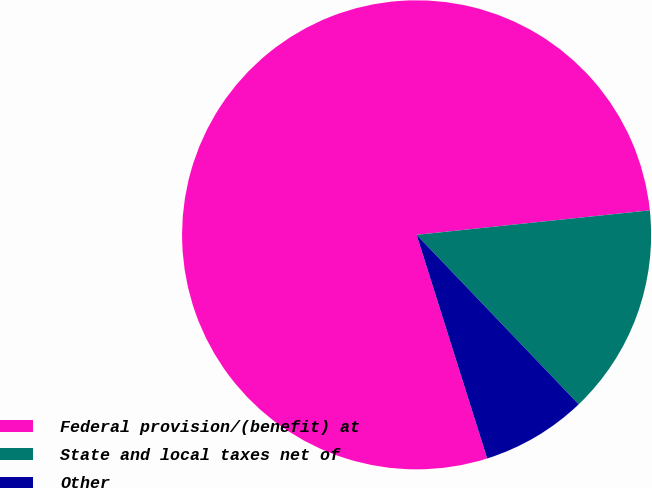Convert chart. <chart><loc_0><loc_0><loc_500><loc_500><pie_chart><fcel>Federal provision/(benefit) at<fcel>State and local taxes net of<fcel>Other<nl><fcel>78.2%<fcel>14.52%<fcel>7.28%<nl></chart> 